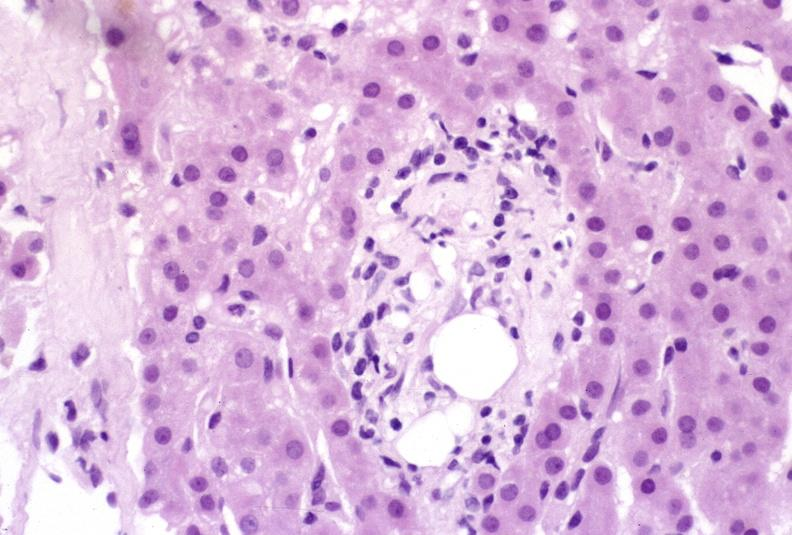what is present?
Answer the question using a single word or phrase. Hepatobiliary 